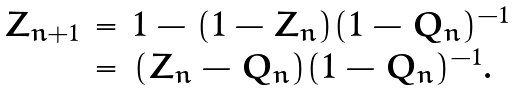Convert formula to latex. <formula><loc_0><loc_0><loc_500><loc_500>\begin{array} { r c l } Z _ { n + 1 } & = & 1 - ( 1 - Z _ { n } ) ( 1 - Q _ { n } ) ^ { - 1 } \\ & = & ( Z _ { n } - Q _ { n } ) ( 1 - Q _ { n } ) ^ { - 1 } . \end{array}</formula> 